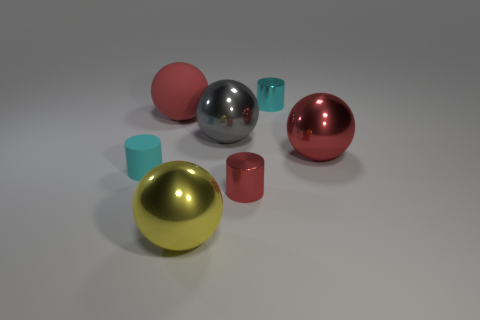Subtract all small red metallic cylinders. How many cylinders are left? 2 Subtract all purple blocks. How many red balls are left? 2 Add 2 big brown rubber blocks. How many objects exist? 9 Subtract all yellow spheres. How many spheres are left? 3 Subtract all spheres. How many objects are left? 3 Subtract all yellow spheres. Subtract all green blocks. How many spheres are left? 3 Subtract all small red metallic cylinders. Subtract all small cyan metallic cylinders. How many objects are left? 5 Add 6 rubber spheres. How many rubber spheres are left? 7 Add 1 cyan objects. How many cyan objects exist? 3 Subtract 0 cyan blocks. How many objects are left? 7 